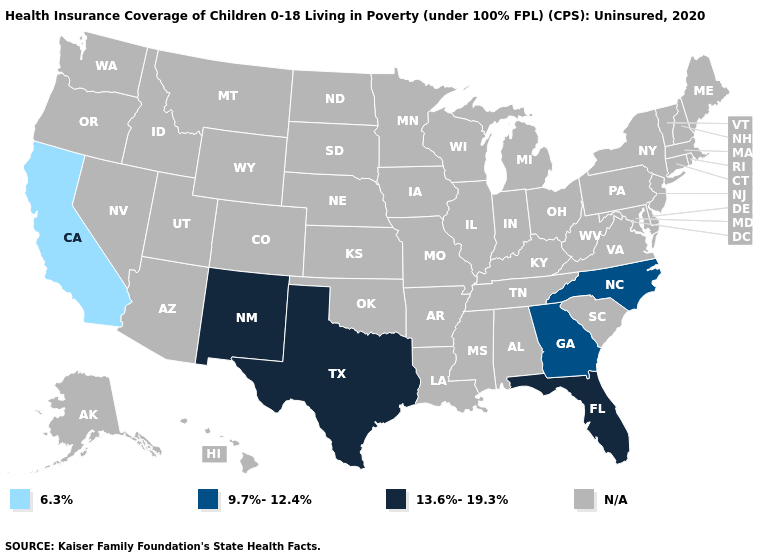Among the states that border Louisiana , which have the highest value?
Keep it brief. Texas. Is the legend a continuous bar?
Be succinct. No. What is the value of Tennessee?
Answer briefly. N/A. What is the lowest value in the West?
Concise answer only. 6.3%. Name the states that have a value in the range 13.6%-19.3%?
Concise answer only. Florida, New Mexico, Texas. Name the states that have a value in the range 9.7%-12.4%?
Give a very brief answer. Georgia, North Carolina. Which states have the lowest value in the West?
Be succinct. California. Does New Mexico have the lowest value in the USA?
Concise answer only. No. Does New Mexico have the lowest value in the USA?
Concise answer only. No. What is the value of Connecticut?
Concise answer only. N/A. 